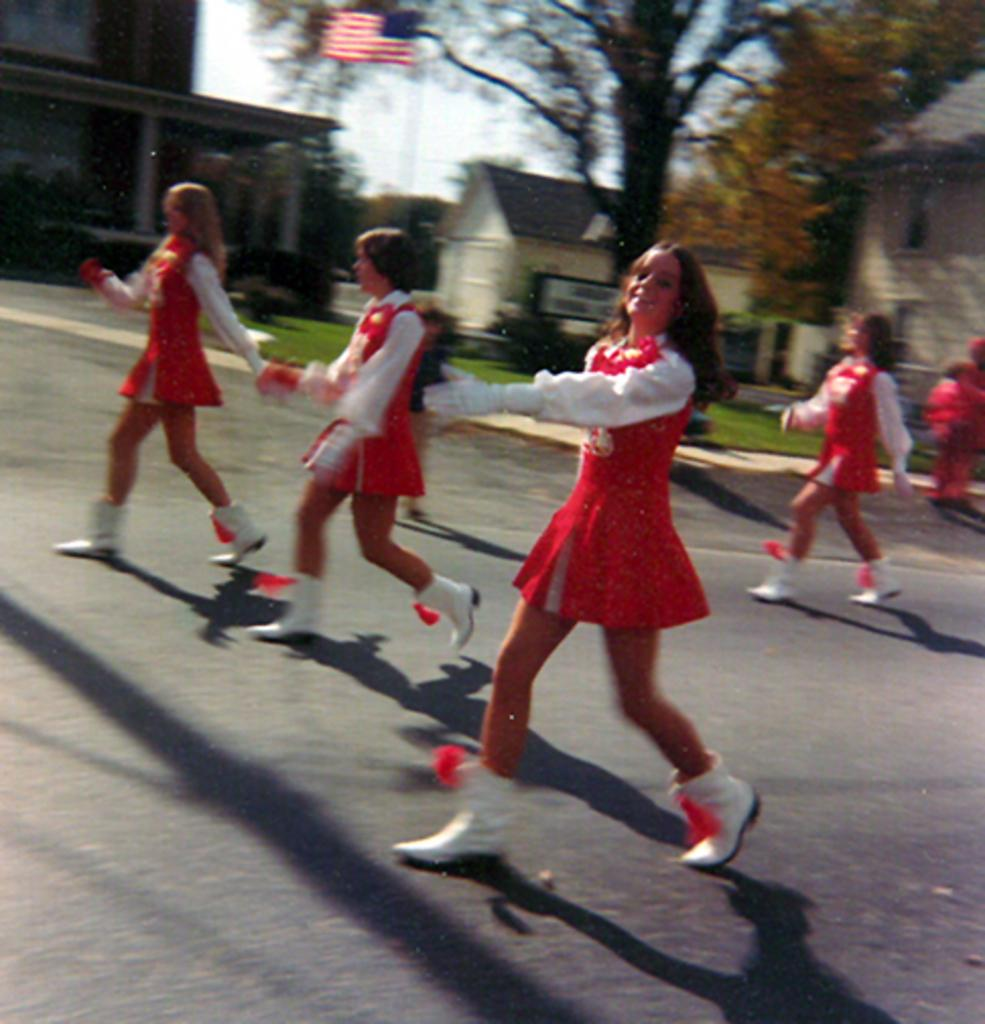What can be seen on the road in the image? There are many girls on the road in the image. What is visible in the background of the image? There is a tree, a flag, buildings, and the sky visible in the background of the image. What type of juice is being served at the agreement meeting in the image? There is no agreement meeting or juice present in the image. How are the girls connected to the buildings in the image? The girls are not connected to the buildings in the image; they are simply on the road in front of them. 